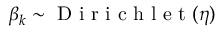<formula> <loc_0><loc_0><loc_500><loc_500>\beta _ { k } \sim D i r i c h l e t ( \eta )</formula> 